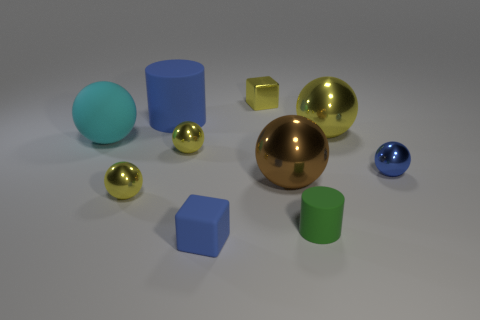Do the big brown object and the big cyan thing have the same shape?
Your answer should be compact. Yes. There is another cylinder that is made of the same material as the blue cylinder; what size is it?
Give a very brief answer. Small. What size is the other rubber object that is the same shape as the green rubber thing?
Offer a very short reply. Large. Are there any small blue balls?
Provide a short and direct response. Yes. What number of objects are yellow objects behind the large cyan matte sphere or tiny blue shiny objects?
Provide a succinct answer. 3. What material is the cylinder that is the same size as the brown shiny object?
Your response must be concise. Rubber. There is a matte cylinder that is in front of the tiny object to the left of the big cylinder; what is its color?
Your response must be concise. Green. How many large rubber balls are in front of the tiny shiny block?
Offer a very short reply. 1. The large cylinder is what color?
Ensure brevity in your answer.  Blue. How many small objects are purple shiny blocks or brown shiny objects?
Your answer should be compact. 0. 